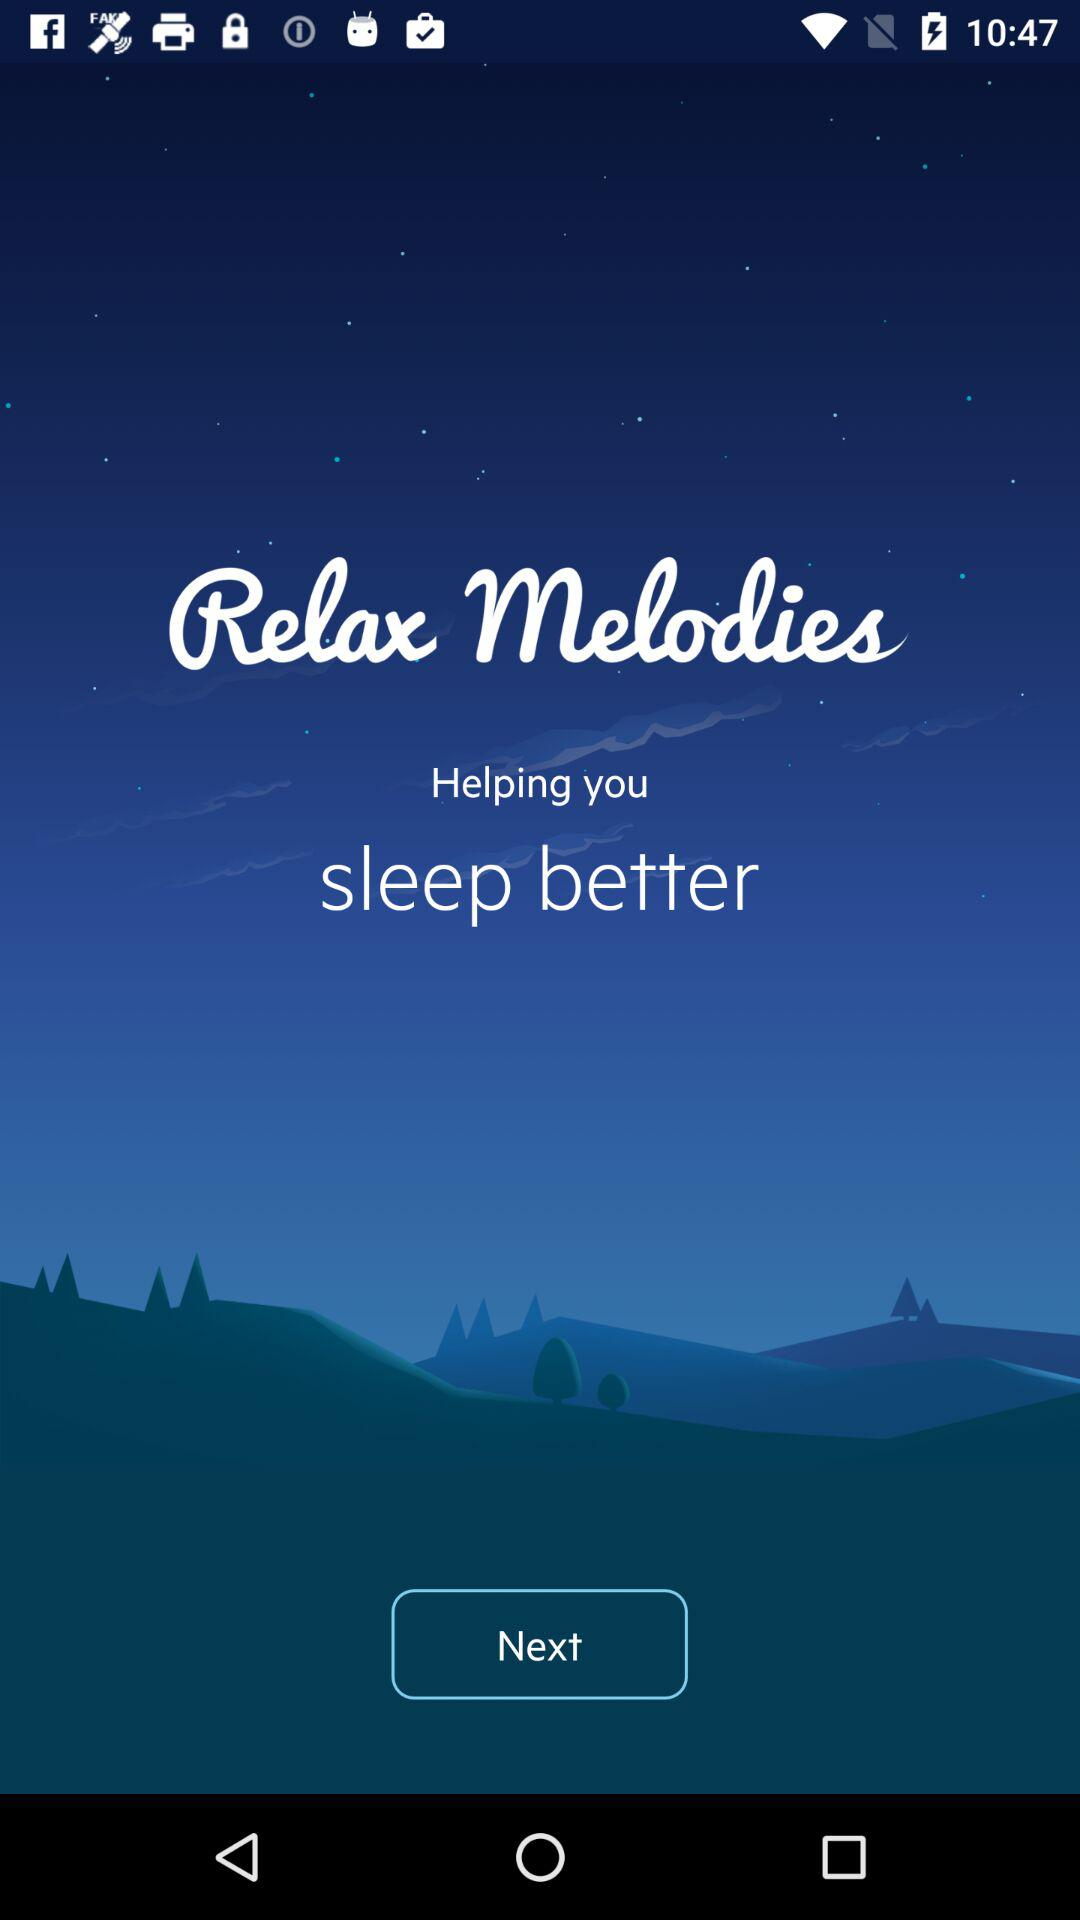Why this application is helpful? This application is helpful for sleeping better. 